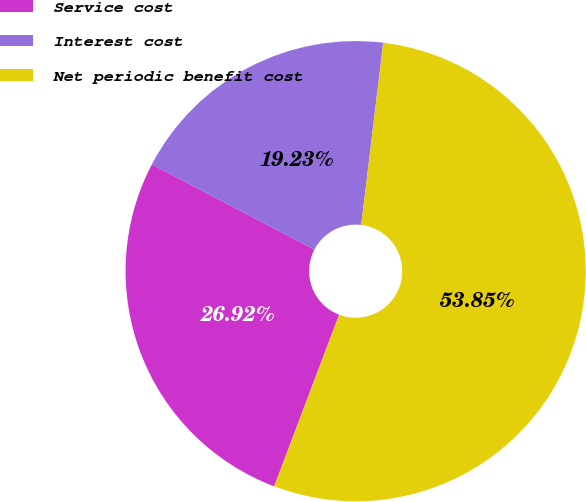<chart> <loc_0><loc_0><loc_500><loc_500><pie_chart><fcel>Service cost<fcel>Interest cost<fcel>Net periodic benefit cost<nl><fcel>26.92%<fcel>19.23%<fcel>53.85%<nl></chart> 